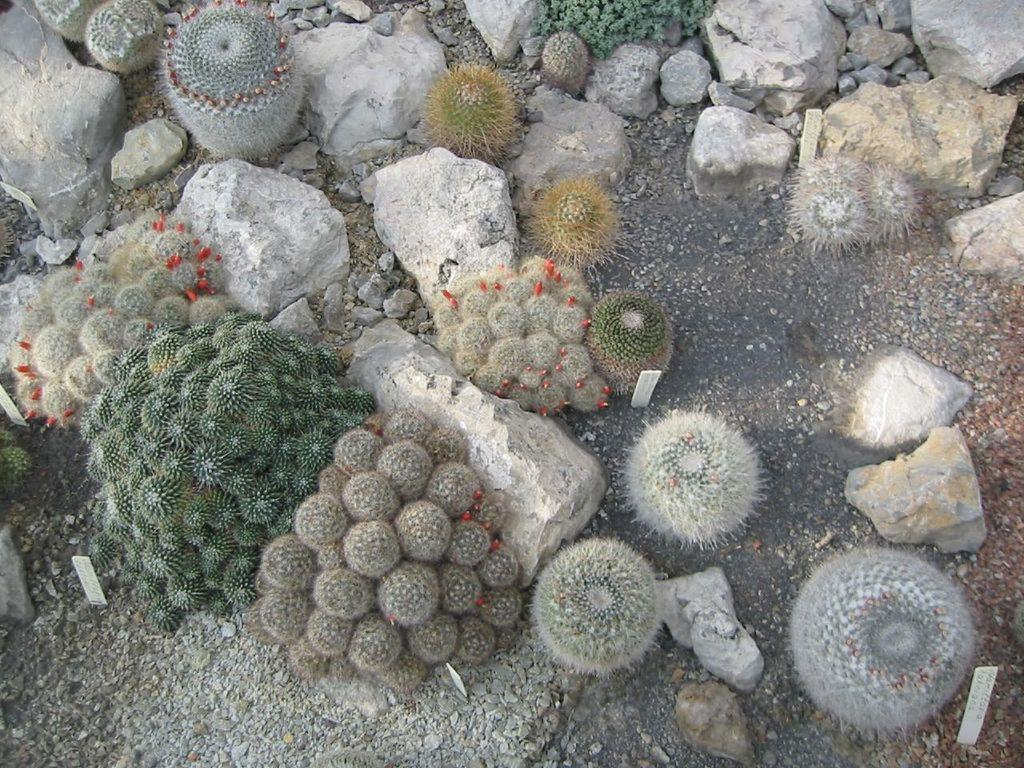What type of living organisms can be seen in the image? Plants can be seen in the image. What other objects are present in the image? There are stones and boards visible in the image. What is the surface on which the plants and stones are placed? The ground is visible in the image. What type of crook can be seen in the image? There is no crook present in the image. How does the support system for the plants look like in the image? The image does not show any support system for the plants; it only shows plants, stones, and boards on the ground. 